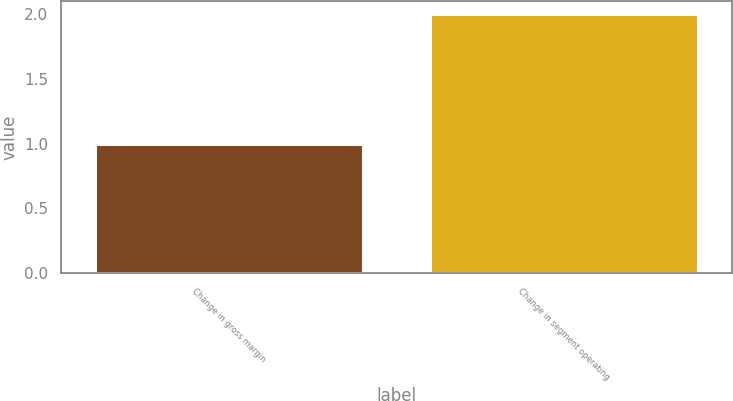<chart> <loc_0><loc_0><loc_500><loc_500><bar_chart><fcel>Change in gross margin<fcel>Change in segment operating<nl><fcel>1<fcel>2<nl></chart> 